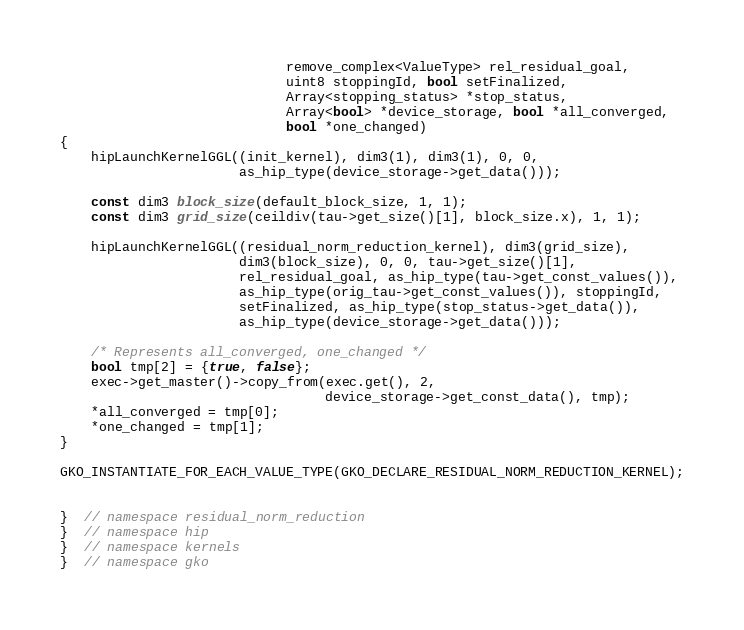Convert code to text. <code><loc_0><loc_0><loc_500><loc_500><_C++_>                             remove_complex<ValueType> rel_residual_goal,
                             uint8 stoppingId, bool setFinalized,
                             Array<stopping_status> *stop_status,
                             Array<bool> *device_storage, bool *all_converged,
                             bool *one_changed)
{
    hipLaunchKernelGGL((init_kernel), dim3(1), dim3(1), 0, 0,
                       as_hip_type(device_storage->get_data()));

    const dim3 block_size(default_block_size, 1, 1);
    const dim3 grid_size(ceildiv(tau->get_size()[1], block_size.x), 1, 1);

    hipLaunchKernelGGL((residual_norm_reduction_kernel), dim3(grid_size),
                       dim3(block_size), 0, 0, tau->get_size()[1],
                       rel_residual_goal, as_hip_type(tau->get_const_values()),
                       as_hip_type(orig_tau->get_const_values()), stoppingId,
                       setFinalized, as_hip_type(stop_status->get_data()),
                       as_hip_type(device_storage->get_data()));

    /* Represents all_converged, one_changed */
    bool tmp[2] = {true, false};
    exec->get_master()->copy_from(exec.get(), 2,
                                  device_storage->get_const_data(), tmp);
    *all_converged = tmp[0];
    *one_changed = tmp[1];
}

GKO_INSTANTIATE_FOR_EACH_VALUE_TYPE(GKO_DECLARE_RESIDUAL_NORM_REDUCTION_KERNEL);


}  // namespace residual_norm_reduction
}  // namespace hip
}  // namespace kernels
}  // namespace gko
</code> 